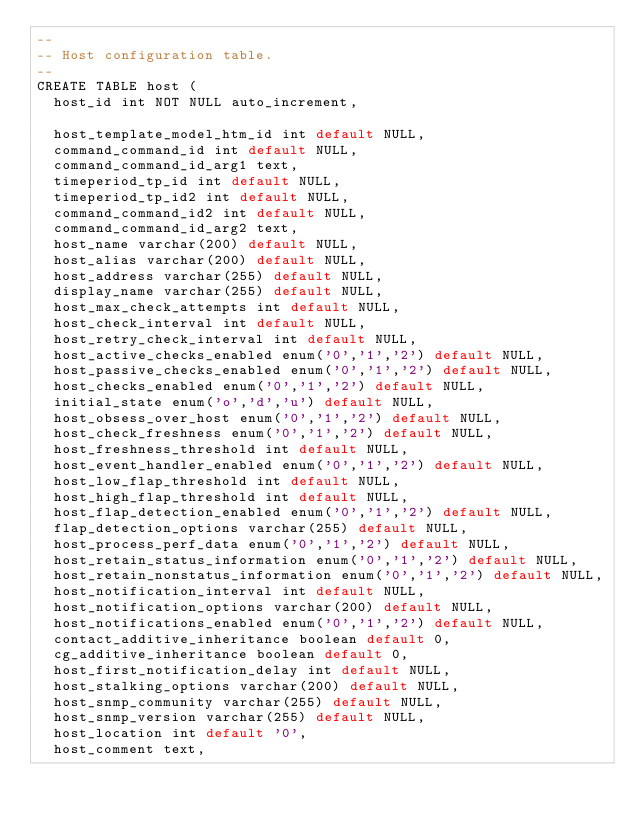Convert code to text. <code><loc_0><loc_0><loc_500><loc_500><_SQL_>--
-- Host configuration table.
--
CREATE TABLE host (
  host_id int NOT NULL auto_increment,

  host_template_model_htm_id int default NULL,
  command_command_id int default NULL,
  command_command_id_arg1 text,
  timeperiod_tp_id int default NULL,
  timeperiod_tp_id2 int default NULL,
  command_command_id2 int default NULL,
  command_command_id_arg2 text,
  host_name varchar(200) default NULL,
  host_alias varchar(200) default NULL,
  host_address varchar(255) default NULL,
  display_name varchar(255) default NULL,
  host_max_check_attempts int default NULL,
  host_check_interval int default NULL,
  host_retry_check_interval int default NULL,
  host_active_checks_enabled enum('0','1','2') default NULL,
  host_passive_checks_enabled enum('0','1','2') default NULL,
  host_checks_enabled enum('0','1','2') default NULL,
  initial_state enum('o','d','u') default NULL,
  host_obsess_over_host enum('0','1','2') default NULL,
  host_check_freshness enum('0','1','2') default NULL,
  host_freshness_threshold int default NULL,
  host_event_handler_enabled enum('0','1','2') default NULL,
  host_low_flap_threshold int default NULL,
  host_high_flap_threshold int default NULL,
  host_flap_detection_enabled enum('0','1','2') default NULL,
  flap_detection_options varchar(255) default NULL,
  host_process_perf_data enum('0','1','2') default NULL,
  host_retain_status_information enum('0','1','2') default NULL,
  host_retain_nonstatus_information enum('0','1','2') default NULL,
  host_notification_interval int default NULL,
  host_notification_options varchar(200) default NULL,
  host_notifications_enabled enum('0','1','2') default NULL,
  contact_additive_inheritance boolean default 0,
  cg_additive_inheritance boolean default 0,
  host_first_notification_delay int default NULL,
  host_stalking_options varchar(200) default NULL,
  host_snmp_community varchar(255) default NULL,
  host_snmp_version varchar(255) default NULL,
  host_location int default '0',
  host_comment text,</code> 